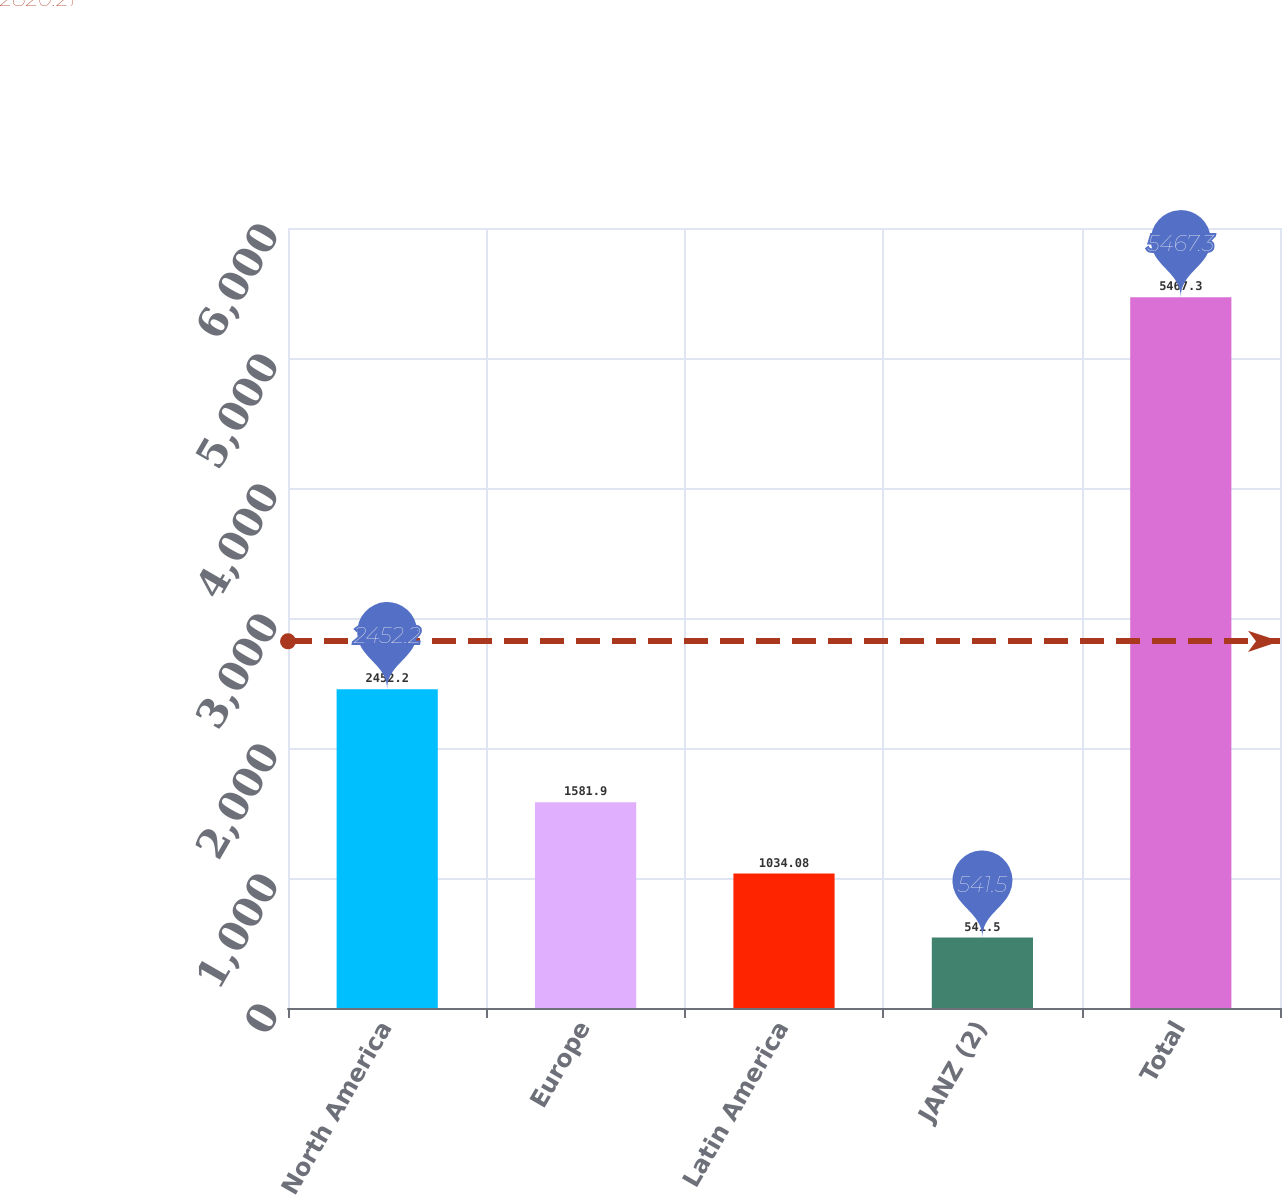<chart> <loc_0><loc_0><loc_500><loc_500><bar_chart><fcel>North America<fcel>Europe<fcel>Latin America<fcel>JANZ (2)<fcel>Total<nl><fcel>2452.2<fcel>1581.9<fcel>1034.08<fcel>541.5<fcel>5467.3<nl></chart> 